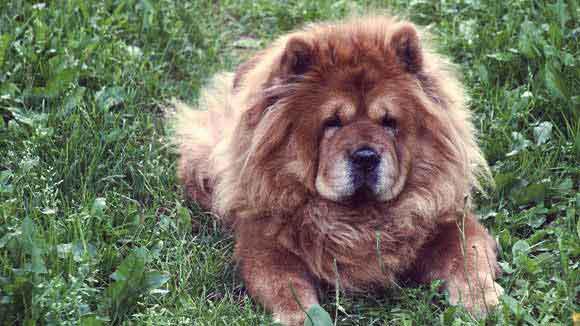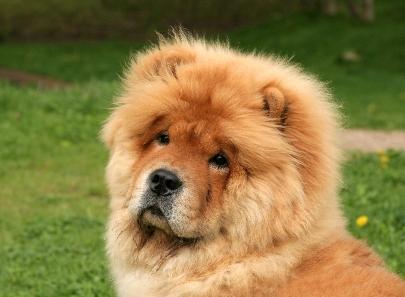The first image is the image on the left, the second image is the image on the right. Considering the images on both sides, is "There are only two dogs total and none are laying down." valid? Answer yes or no. No. The first image is the image on the left, the second image is the image on the right. For the images shown, is this caption "In at least one image there is a tan fluffy dog sitting in the grass" true? Answer yes or no. Yes. 